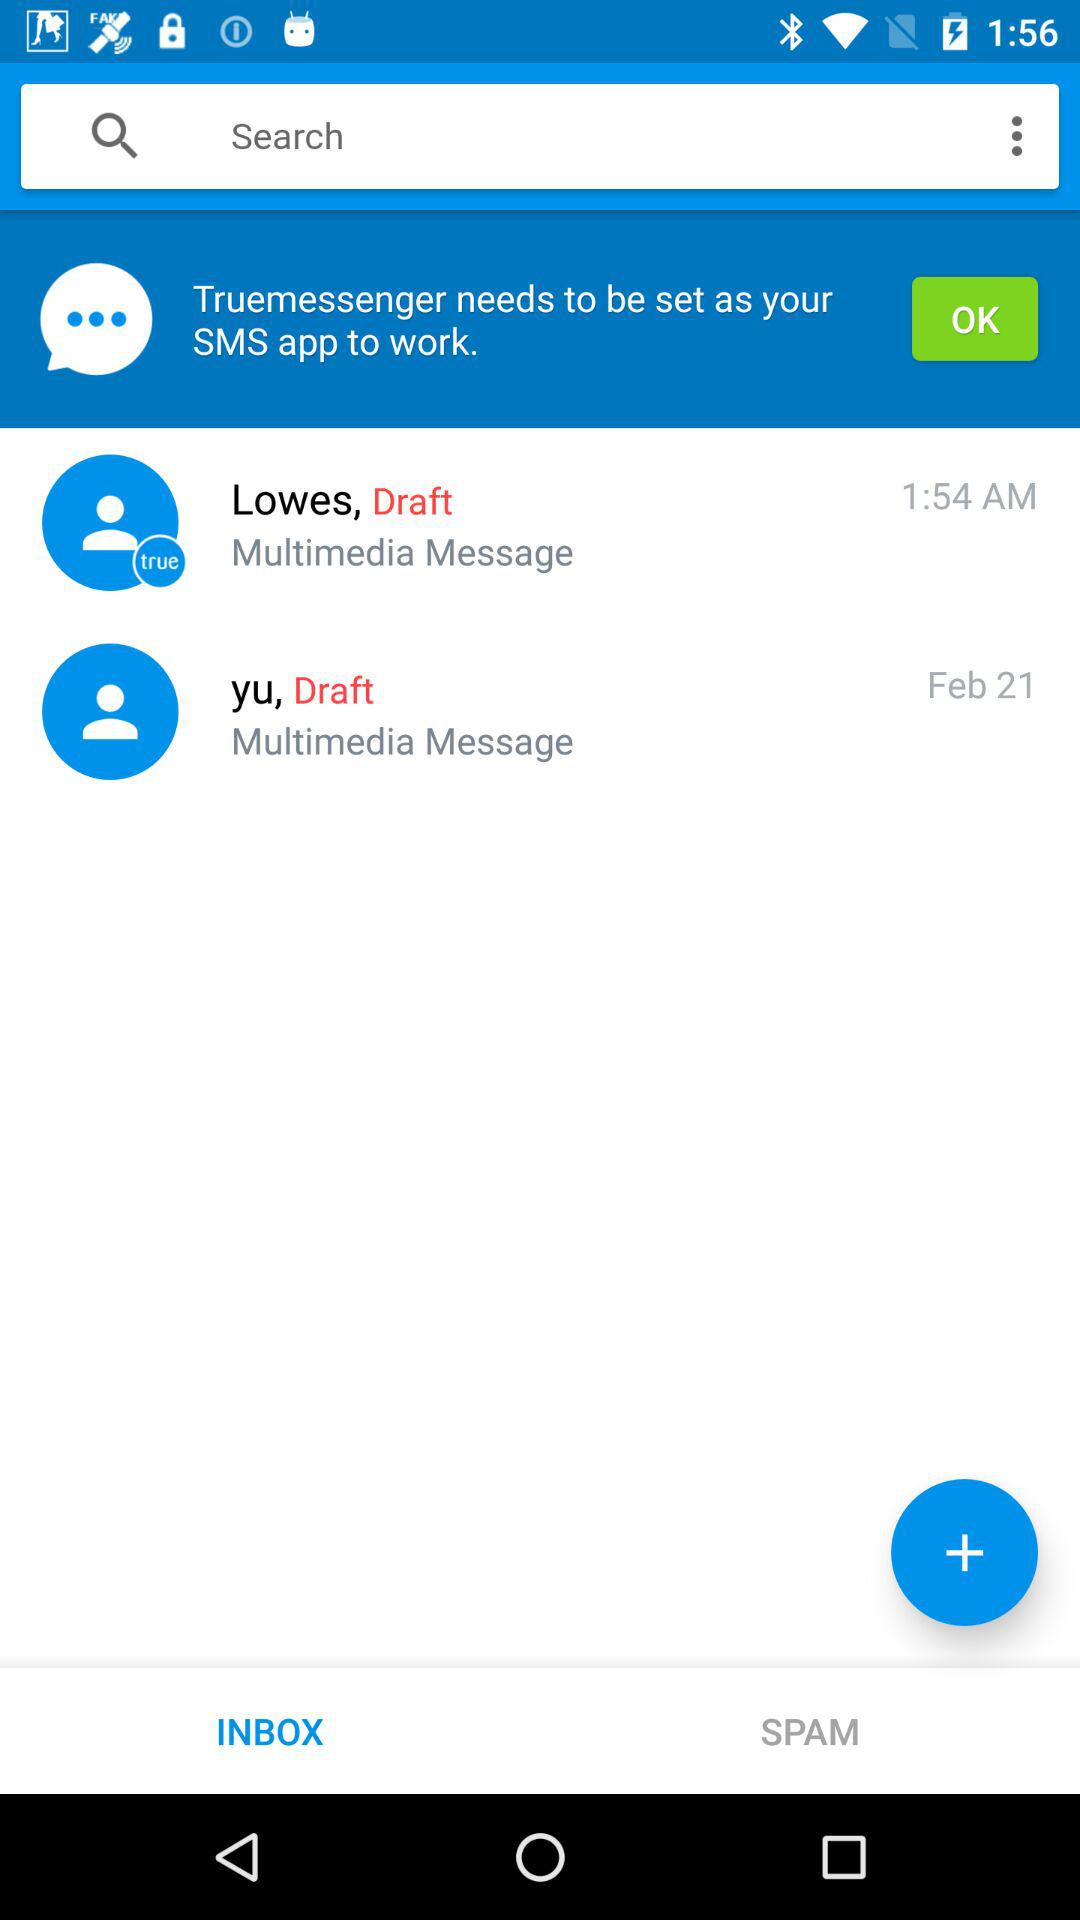How many unread messages are there?
Answer the question using a single word or phrase. 2 